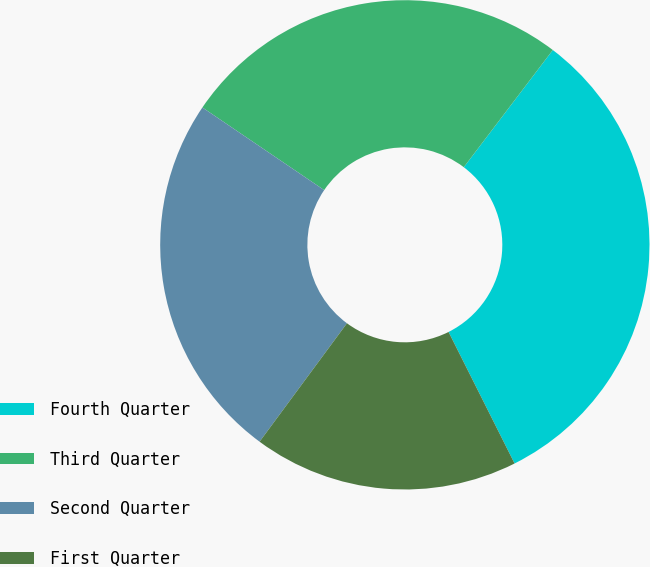Convert chart to OTSL. <chart><loc_0><loc_0><loc_500><loc_500><pie_chart><fcel>Fourth Quarter<fcel>Third Quarter<fcel>Second Quarter<fcel>First Quarter<nl><fcel>32.26%<fcel>25.85%<fcel>24.37%<fcel>17.52%<nl></chart> 